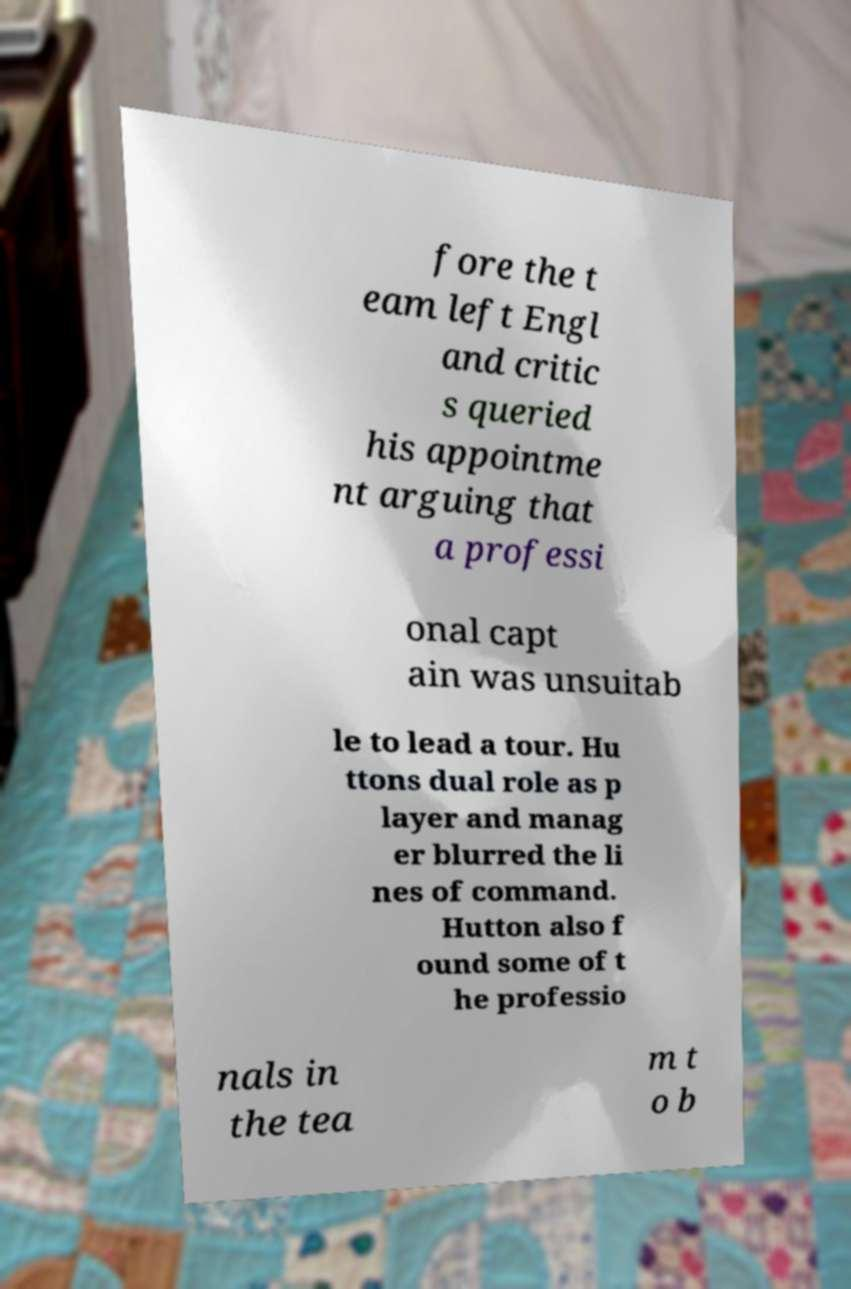For documentation purposes, I need the text within this image transcribed. Could you provide that? fore the t eam left Engl and critic s queried his appointme nt arguing that a professi onal capt ain was unsuitab le to lead a tour. Hu ttons dual role as p layer and manag er blurred the li nes of command. Hutton also f ound some of t he professio nals in the tea m t o b 